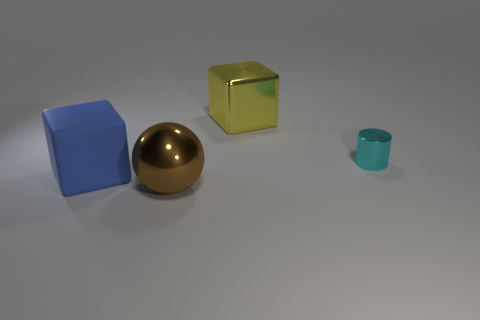Are there more big blue rubber objects on the right side of the blue object than tiny shiny objects? Upon reviewing the scene, there appears to be one big blue rubber object on the left, and one tiny shiny object, which is a small golden sphere. The number of big blue rubber objects and tiny shiny objects are equal, with neither having more on any side of the blue object. 